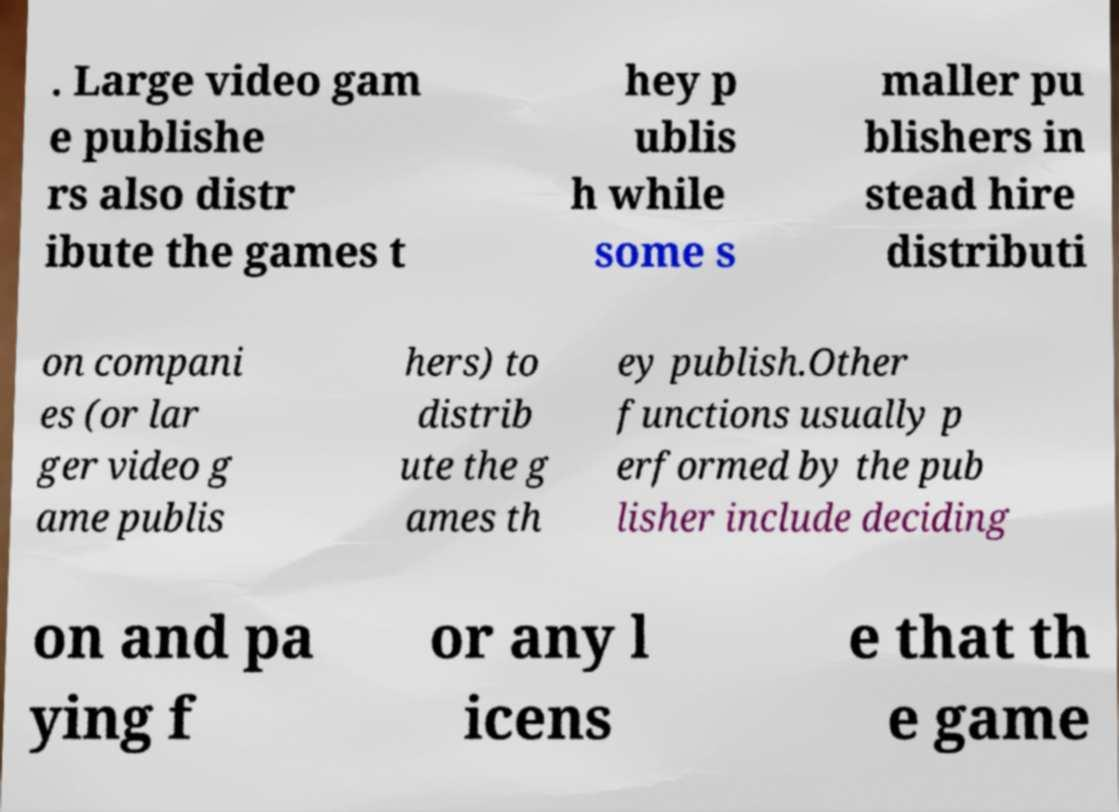There's text embedded in this image that I need extracted. Can you transcribe it verbatim? . Large video gam e publishe rs also distr ibute the games t hey p ublis h while some s maller pu blishers in stead hire distributi on compani es (or lar ger video g ame publis hers) to distrib ute the g ames th ey publish.Other functions usually p erformed by the pub lisher include deciding on and pa ying f or any l icens e that th e game 